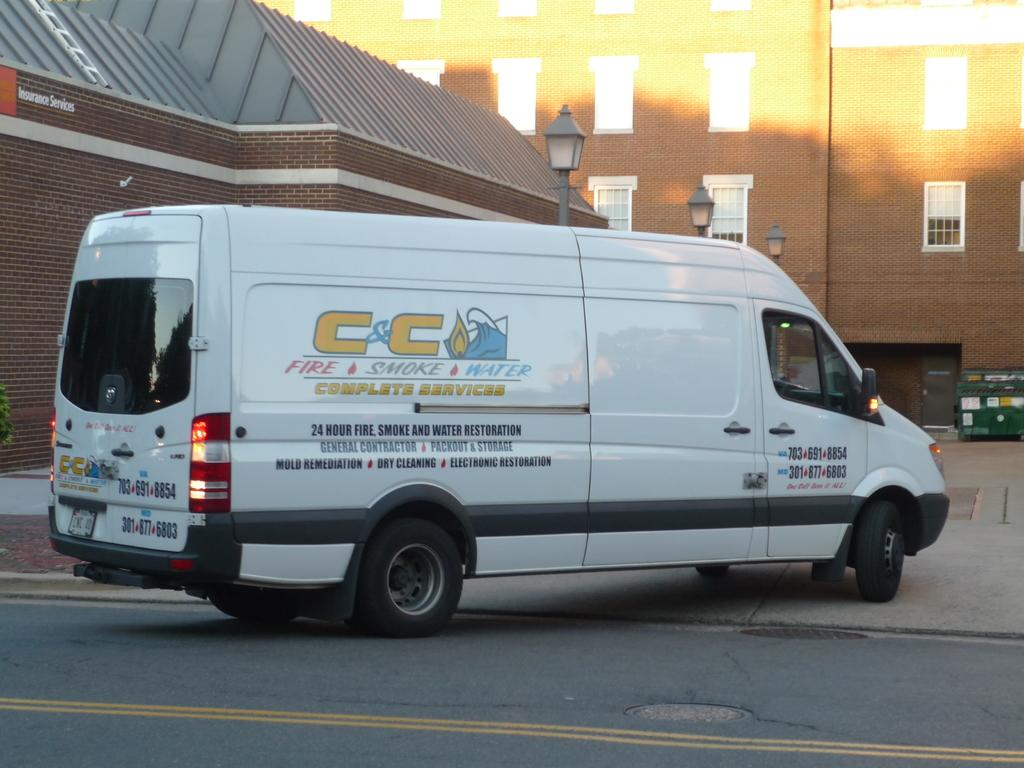<image>
Summarize the visual content of the image. a van that has the letters CC on it 